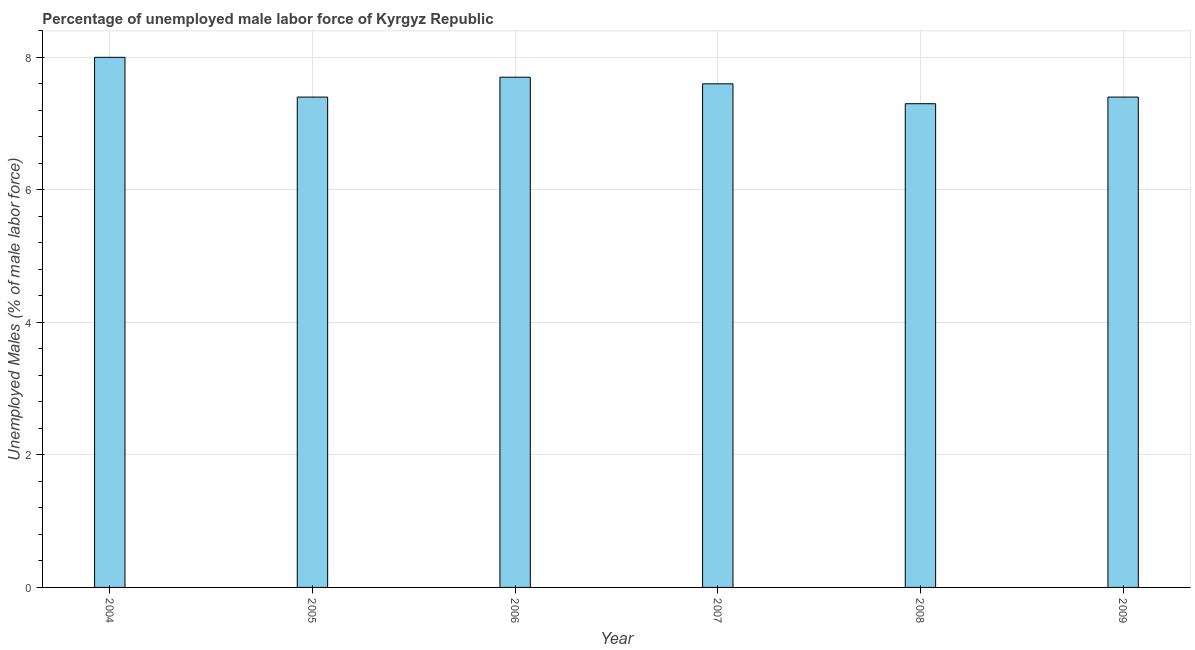Does the graph contain any zero values?
Your response must be concise. No. Does the graph contain grids?
Your answer should be very brief. Yes. What is the title of the graph?
Give a very brief answer. Percentage of unemployed male labor force of Kyrgyz Republic. What is the label or title of the Y-axis?
Ensure brevity in your answer.  Unemployed Males (% of male labor force). What is the total unemployed male labour force in 2007?
Make the answer very short. 7.6. Across all years, what is the minimum total unemployed male labour force?
Your response must be concise. 7.3. In which year was the total unemployed male labour force minimum?
Your answer should be very brief. 2008. What is the sum of the total unemployed male labour force?
Your response must be concise. 45.4. What is the average total unemployed male labour force per year?
Give a very brief answer. 7.57. What is the median total unemployed male labour force?
Your answer should be very brief. 7.5. What is the ratio of the total unemployed male labour force in 2004 to that in 2006?
Provide a succinct answer. 1.04. Is the sum of the total unemployed male labour force in 2006 and 2009 greater than the maximum total unemployed male labour force across all years?
Offer a very short reply. Yes. In how many years, is the total unemployed male labour force greater than the average total unemployed male labour force taken over all years?
Your response must be concise. 3. How many years are there in the graph?
Provide a succinct answer. 6. What is the difference between two consecutive major ticks on the Y-axis?
Make the answer very short. 2. Are the values on the major ticks of Y-axis written in scientific E-notation?
Give a very brief answer. No. What is the Unemployed Males (% of male labor force) of 2004?
Keep it short and to the point. 8. What is the Unemployed Males (% of male labor force) of 2005?
Ensure brevity in your answer.  7.4. What is the Unemployed Males (% of male labor force) in 2006?
Provide a succinct answer. 7.7. What is the Unemployed Males (% of male labor force) in 2007?
Ensure brevity in your answer.  7.6. What is the Unemployed Males (% of male labor force) in 2008?
Your answer should be very brief. 7.3. What is the Unemployed Males (% of male labor force) of 2009?
Your answer should be compact. 7.4. What is the difference between the Unemployed Males (% of male labor force) in 2004 and 2005?
Your answer should be compact. 0.6. What is the difference between the Unemployed Males (% of male labor force) in 2004 and 2006?
Provide a short and direct response. 0.3. What is the difference between the Unemployed Males (% of male labor force) in 2004 and 2007?
Provide a succinct answer. 0.4. What is the difference between the Unemployed Males (% of male labor force) in 2004 and 2009?
Offer a terse response. 0.6. What is the difference between the Unemployed Males (% of male labor force) in 2005 and 2006?
Your answer should be compact. -0.3. What is the difference between the Unemployed Males (% of male labor force) in 2005 and 2009?
Offer a very short reply. 0. What is the difference between the Unemployed Males (% of male labor force) in 2006 and 2009?
Provide a short and direct response. 0.3. What is the ratio of the Unemployed Males (% of male labor force) in 2004 to that in 2005?
Keep it short and to the point. 1.08. What is the ratio of the Unemployed Males (% of male labor force) in 2004 to that in 2006?
Provide a succinct answer. 1.04. What is the ratio of the Unemployed Males (% of male labor force) in 2004 to that in 2007?
Provide a short and direct response. 1.05. What is the ratio of the Unemployed Males (% of male labor force) in 2004 to that in 2008?
Provide a succinct answer. 1.1. What is the ratio of the Unemployed Males (% of male labor force) in 2004 to that in 2009?
Make the answer very short. 1.08. What is the ratio of the Unemployed Males (% of male labor force) in 2005 to that in 2008?
Offer a very short reply. 1.01. What is the ratio of the Unemployed Males (% of male labor force) in 2006 to that in 2008?
Provide a succinct answer. 1.05. What is the ratio of the Unemployed Males (% of male labor force) in 2006 to that in 2009?
Provide a short and direct response. 1.04. What is the ratio of the Unemployed Males (% of male labor force) in 2007 to that in 2008?
Make the answer very short. 1.04. What is the ratio of the Unemployed Males (% of male labor force) in 2008 to that in 2009?
Ensure brevity in your answer.  0.99. 